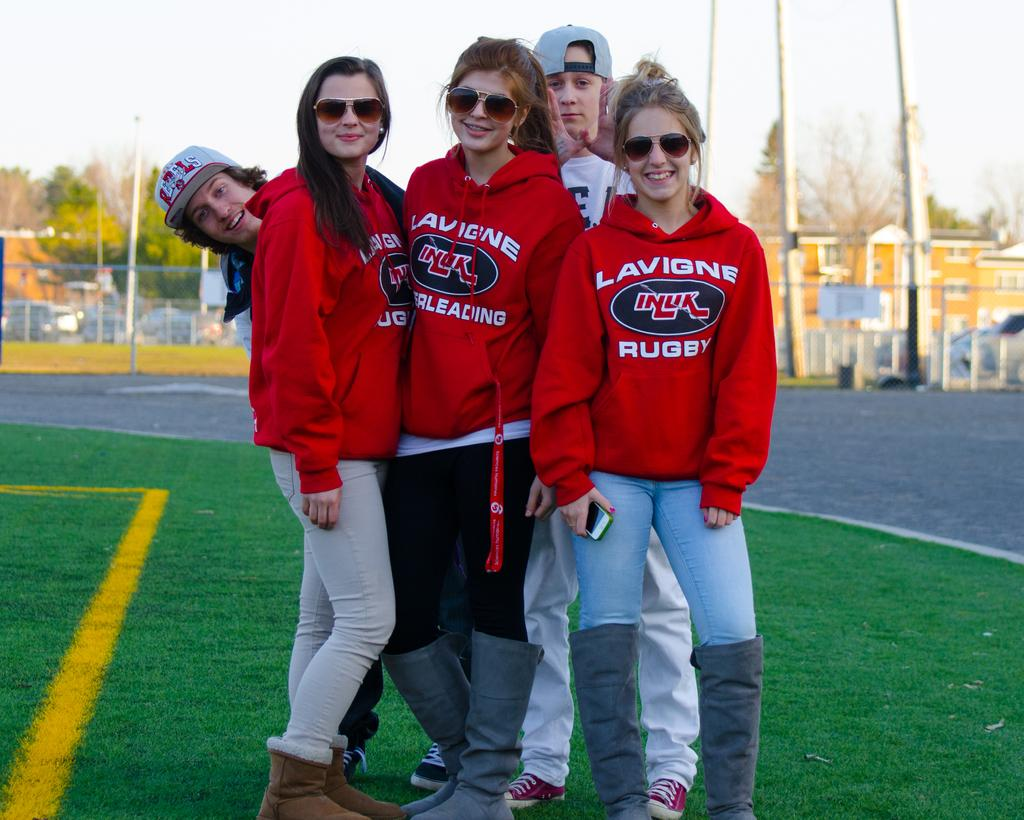<image>
Give a short and clear explanation of the subsequent image. Group of teenagers taking a photo with one of their sweaters saying Lavigne Rugby. 